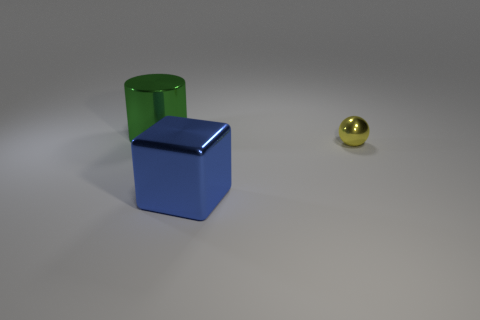Is there any other thing that has the same material as the large green cylinder?
Provide a succinct answer. Yes. Do the large thing that is to the right of the green cylinder and the tiny sphere have the same material?
Provide a succinct answer. Yes. Do the green object and the large blue metallic object have the same shape?
Your response must be concise. No. The big metallic object behind the large shiny object on the right side of the thing left of the big blue object is what shape?
Provide a succinct answer. Cylinder. Is there a small purple object made of the same material as the cylinder?
Your answer should be very brief. No. There is a large metallic thing that is to the left of the big shiny thing that is on the right side of the big thing that is behind the small metal thing; what is its color?
Provide a succinct answer. Green. What shape is the big object to the right of the big shiny cylinder?
Make the answer very short. Cube. What number of objects are large blocks or large metallic objects that are left of the big blue shiny thing?
Offer a terse response. 2. Are there an equal number of big metallic things that are on the right side of the large cube and big metal things left of the ball?
Your answer should be compact. No. What number of large green metallic cylinders are behind the cylinder?
Ensure brevity in your answer.  0. 